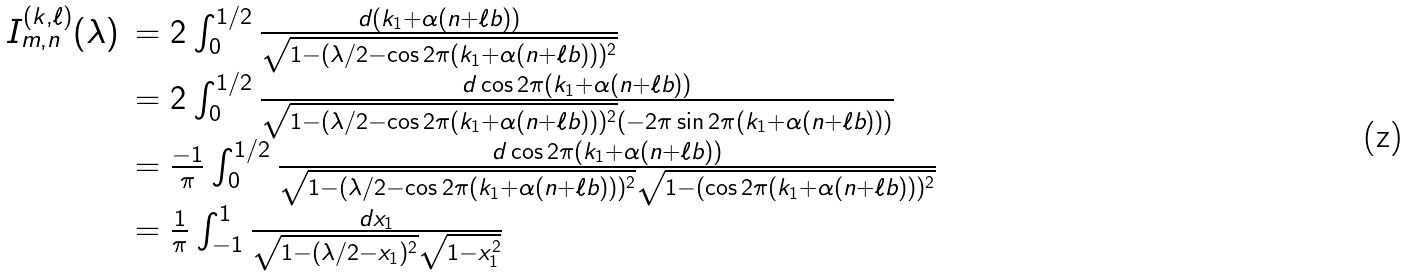Convert formula to latex. <formula><loc_0><loc_0><loc_500><loc_500>\begin{array} { r l } I _ { m , n } ^ { ( k , \ell ) } ( \lambda ) & = 2 \int _ { 0 } ^ { 1 / 2 } \frac { d ( k _ { 1 } + \alpha ( n + \ell b ) ) } { \sqrt { 1 - ( \lambda / 2 - \cos 2 \pi ( k _ { 1 } + \alpha ( n + \ell b ) ) ) ^ { 2 } } } \\ & = 2 \int _ { 0 } ^ { 1 / 2 } \frac { d \cos 2 \pi ( k _ { 1 } + \alpha ( n + \ell b ) ) } { \sqrt { 1 - ( \lambda / 2 - \cos 2 \pi ( k _ { 1 } + \alpha ( n + \ell b ) ) ) ^ { 2 } } ( - 2 \pi \sin 2 \pi ( k _ { 1 } + \alpha ( n + \ell b ) ) ) } \\ & = \frac { - 1 } { \pi } \int _ { 0 } ^ { 1 / 2 } \frac { d \cos 2 \pi ( k _ { 1 } + \alpha ( n + \ell b ) ) } { \sqrt { 1 - ( \lambda / 2 - \cos 2 \pi ( k _ { 1 } + \alpha ( n + \ell b ) ) ) ^ { 2 } } \sqrt { 1 - ( \cos 2 \pi ( k _ { 1 } + \alpha ( n + \ell b ) ) ) ^ { 2 } } } \\ & = \frac { 1 } { \pi } \int ^ { 1 } _ { - 1 } \frac { d x _ { 1 } } { \sqrt { 1 - ( \lambda / 2 - x _ { 1 } ) ^ { 2 } } \sqrt { 1 - x _ { 1 } ^ { 2 } } } \end{array}</formula> 